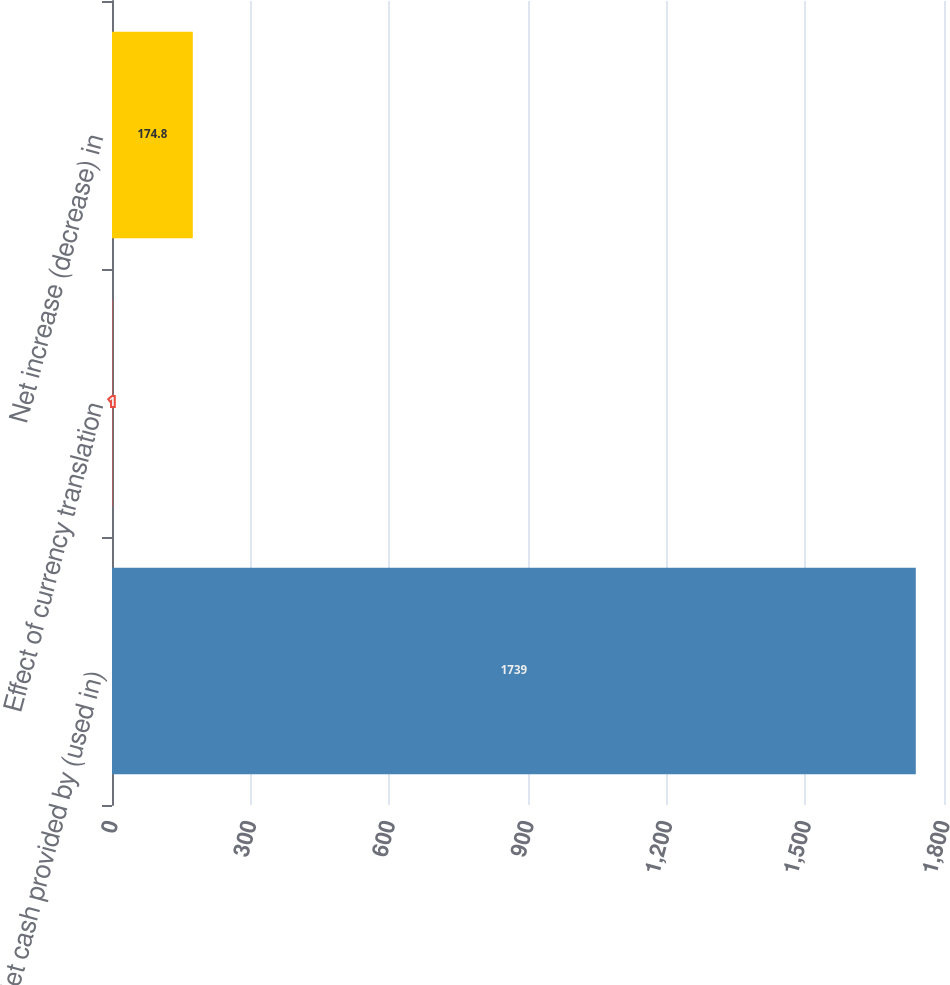<chart> <loc_0><loc_0><loc_500><loc_500><bar_chart><fcel>Net cash provided by (used in)<fcel>Effect of currency translation<fcel>Net increase (decrease) in<nl><fcel>1739<fcel>1<fcel>174.8<nl></chart> 